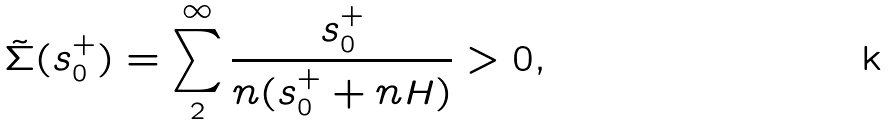<formula> <loc_0><loc_0><loc_500><loc_500>\tilde { \Sigma } ( s ^ { + } _ { 0 } ) = \sum _ { 2 } ^ { \infty } \frac { s ^ { + } _ { 0 } } { n ( s ^ { + } _ { 0 } + n H ) } > 0 ,</formula> 